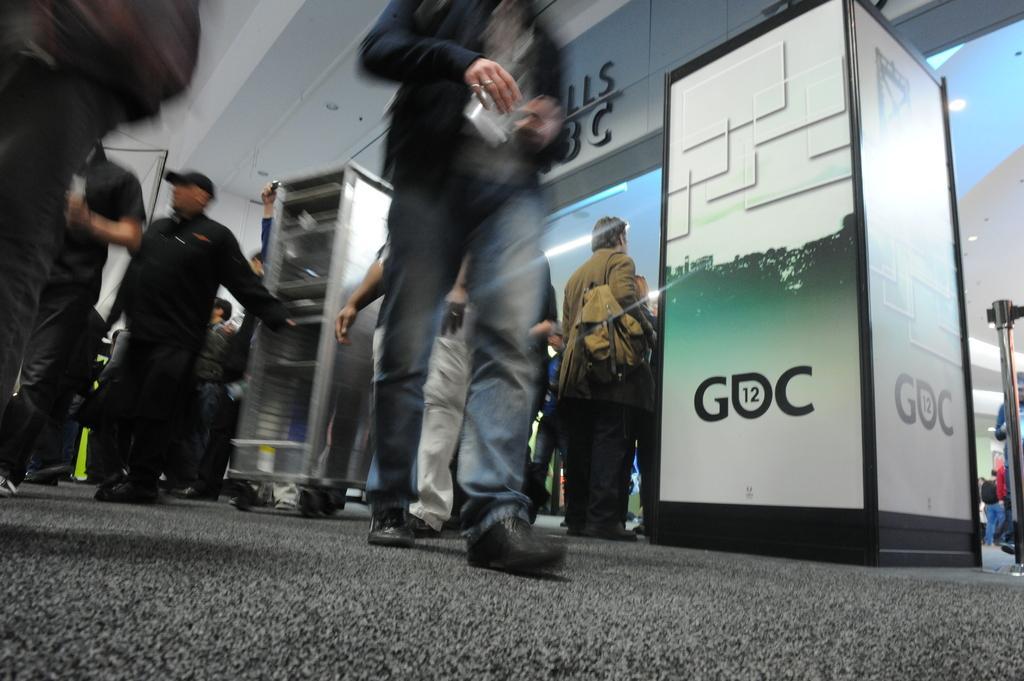Could you give a brief overview of what you see in this image? In this image, we can see persons wearing clothes. There is a rack in the middle of the image. There is a barricade stand on the right side of the image. 